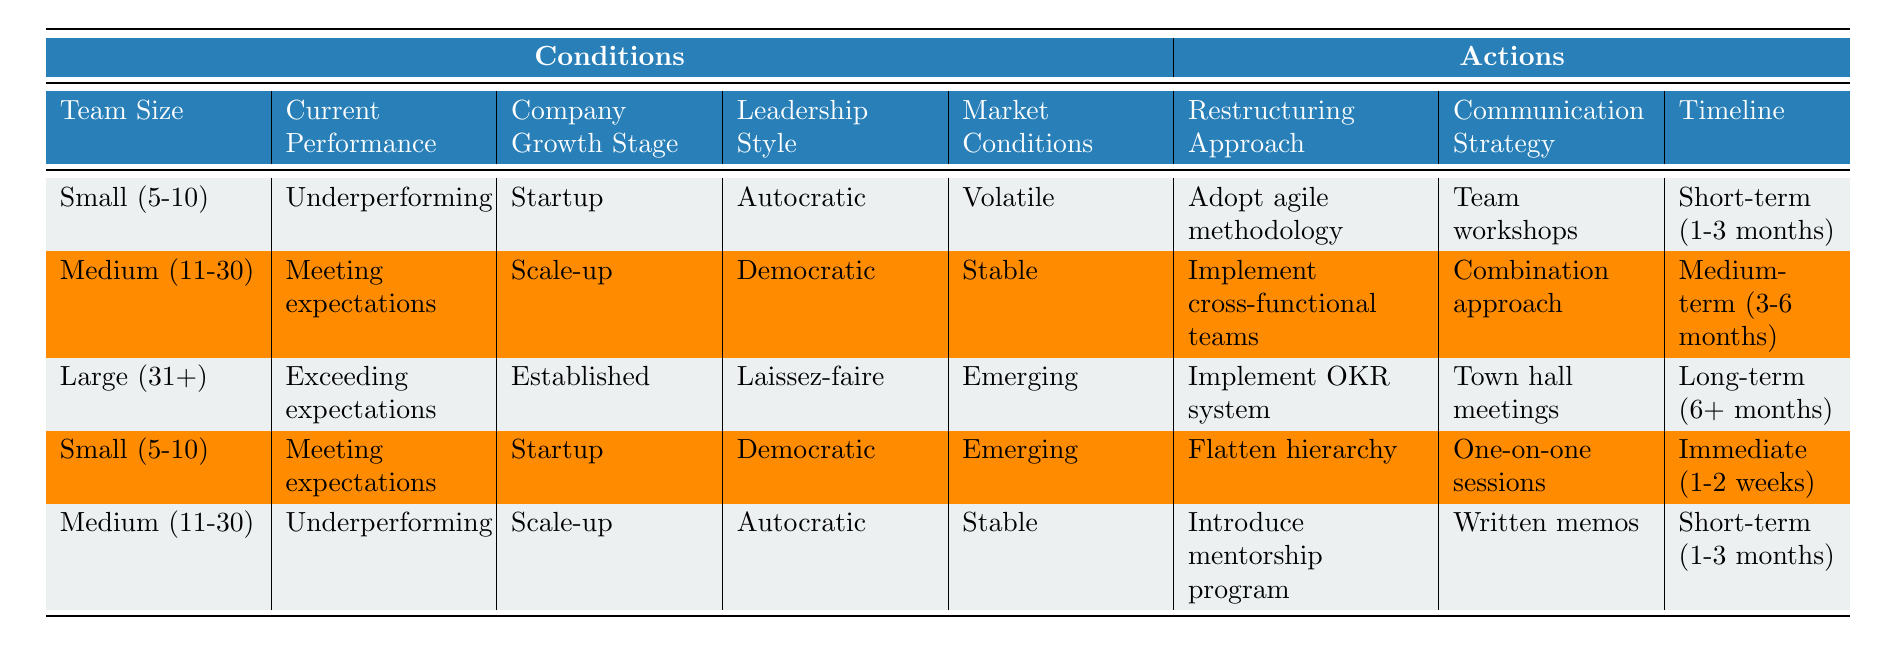What is the restructuring approach for a medium-sized team that is underperforming in a stable market during the scale-up phase? To answer this question, locate the row corresponding to a medium team size (11-30), underperforming current performance, stable market conditions, and scale-up growth stage. From the table, this combination indicates the action to "Introduce mentorship program."
Answer: Introduce mentorship program Which team size has a restructuring approach that involves flattening the hierarchy? The table reveals that a small team (5-10) with a meeting expectations performance in the startup phase and emerging market conditions indicates a restructuring approach of flattening the hierarchy.
Answer: Small (5-10) True or False: A large team that exceeds expectations in an established company should adopt an agile methodology. Referring to the table, a large team (31+) exceeding expectations in an established phase with emerging market conditions does not indicate adopting an agile methodology; instead, it suggests implementing the OKR system. Therefore, the statement is false.
Answer: False What is the communication strategy for a small, underperforming team in a volatile market at the startup stage? The row for a small team (5-10), underperforming, in the startup stage with volatile market conditions lists the communication strategy as "Team workshops." So, that is the required answer.
Answer: Team workshops How many different approaches are listed for restructuring based on various conditions? The table enumerates six unique restructuring approaches: adopt agile methodology, implement cross-functional teams, implement OKR system, flatten hierarchy, introduce mentorship program, and maintain current structure. Counting these options provides a total of six different approaches.
Answer: Six In a summary, what is the timeline for implementing the OKR system for a large team that is exceeding expectations? By locating the row for a large team (31+) exceeding expectations in the established phase and emerging market conditions, the timeline for implementing the OKR system is indicated as long-term (6+ months).
Answer: Long-term (6+ months) Which communication strategies are associated with underperforming teams across the different sizes? For underperforming teams, the table reveals two communication strategies: "Team workshops" for small teams and "Written memos" for medium teams. Hence, these are the strategies for each respective size and their underperforming status.
Answer: Team workshops, Written memos What is the difference in timelines for restructuring between a medium-sized team meeting expectations and a small team underperforming? A medium-sized team meeting expectations in a stable market has a timeline of medium-term (3-6 months), while a small underperforming team has a timeline of short-term (1-3 months). The difference in months is calculated as follows: 6 months - 1 month = 5 months. Thus, the timeline difference between the two is five months.
Answer: Five months 